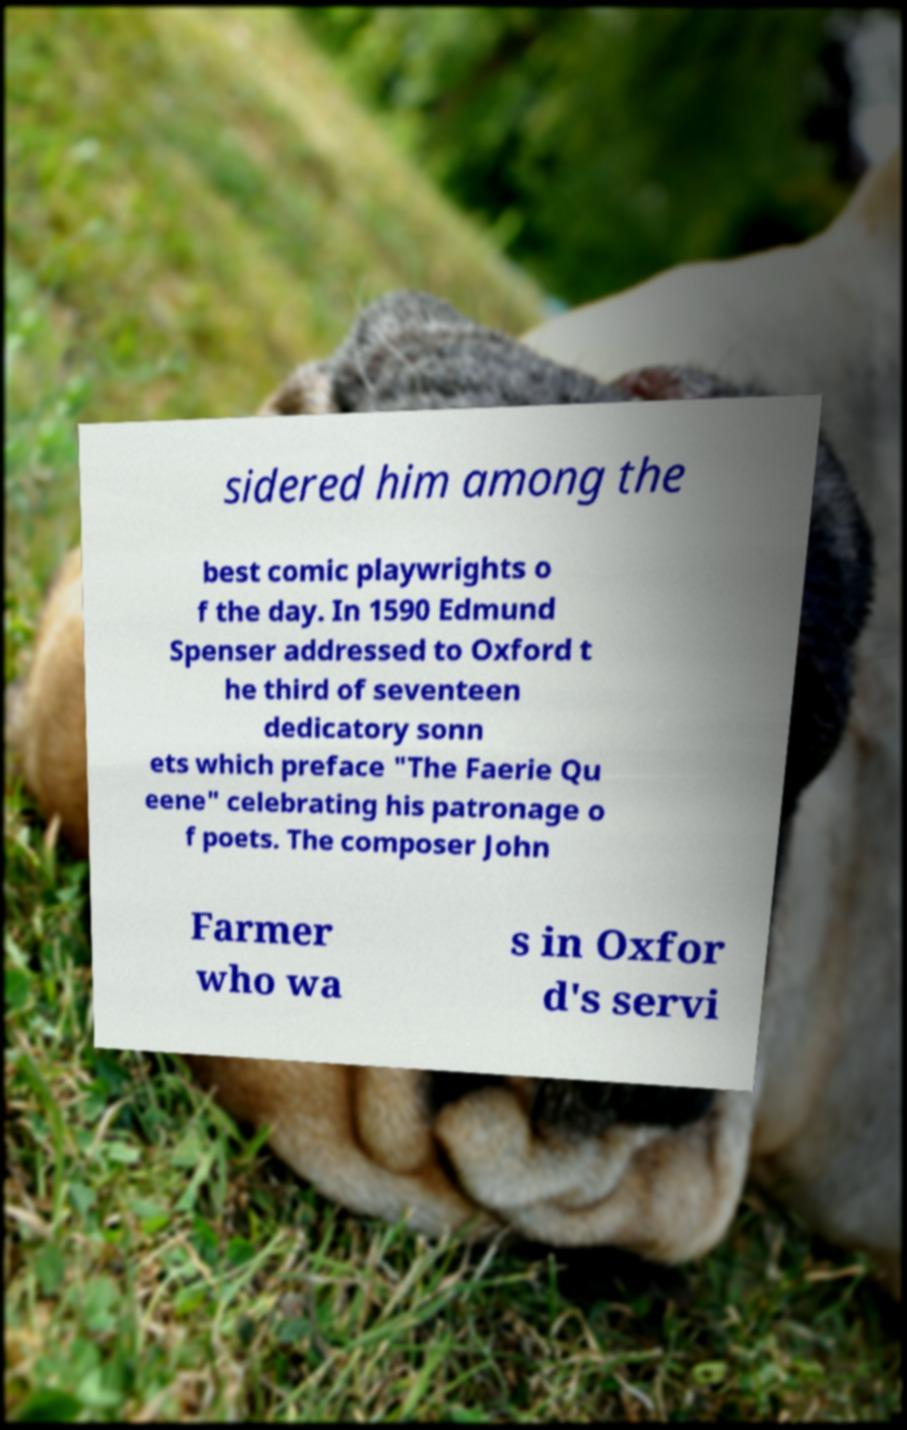What messages or text are displayed in this image? I need them in a readable, typed format. sidered him among the best comic playwrights o f the day. In 1590 Edmund Spenser addressed to Oxford t he third of seventeen dedicatory sonn ets which preface "The Faerie Qu eene" celebrating his patronage o f poets. The composer John Farmer who wa s in Oxfor d's servi 